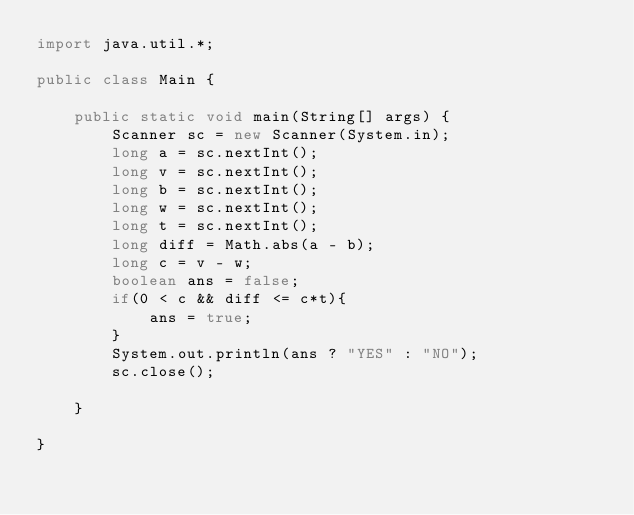<code> <loc_0><loc_0><loc_500><loc_500><_Java_>import java.util.*;

public class Main {

    public static void main(String[] args) {
        Scanner sc = new Scanner(System.in);
        long a = sc.nextInt();
        long v = sc.nextInt();
        long b = sc.nextInt();
        long w = sc.nextInt();
        long t = sc.nextInt();
        long diff = Math.abs(a - b);
        long c = v - w;
        boolean ans = false;
        if(0 < c && diff <= c*t){
            ans = true;
        }
        System.out.println(ans ? "YES" : "NO");
        sc.close();

    }

}
</code> 